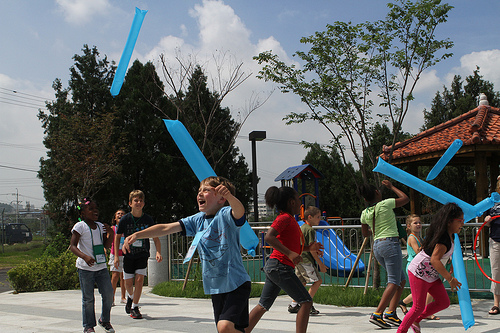<image>
Can you confirm if the child is on the slide? No. The child is not positioned on the slide. They may be near each other, but the child is not supported by or resting on top of the slide. Where is the shoe in relation to the boy? Is it behind the boy? Yes. From this viewpoint, the shoe is positioned behind the boy, with the boy partially or fully occluding the shoe. Is there a girl to the right of the boy? No. The girl is not to the right of the boy. The horizontal positioning shows a different relationship. 